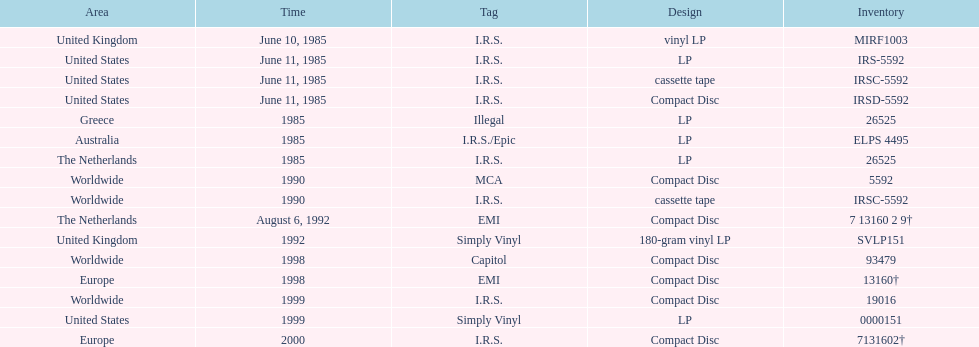Name another region for the 1985 release other than greece. Australia. 